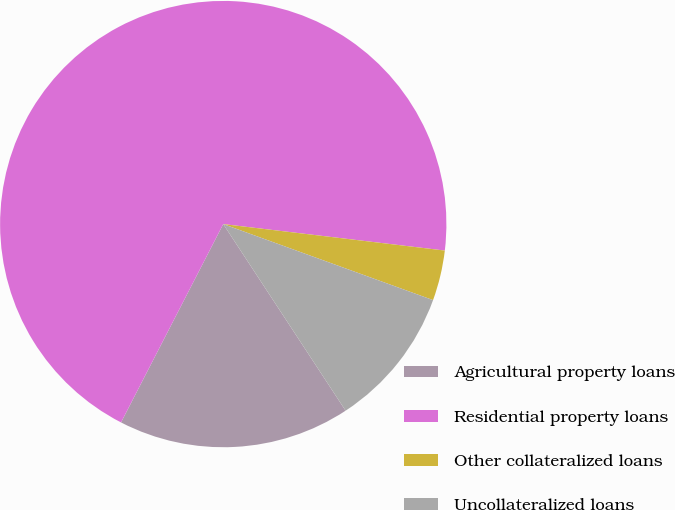Convert chart to OTSL. <chart><loc_0><loc_0><loc_500><loc_500><pie_chart><fcel>Agricultural property loans<fcel>Residential property loans<fcel>Other collateralized loans<fcel>Uncollateralized loans<nl><fcel>16.81%<fcel>69.32%<fcel>3.64%<fcel>10.23%<nl></chart> 